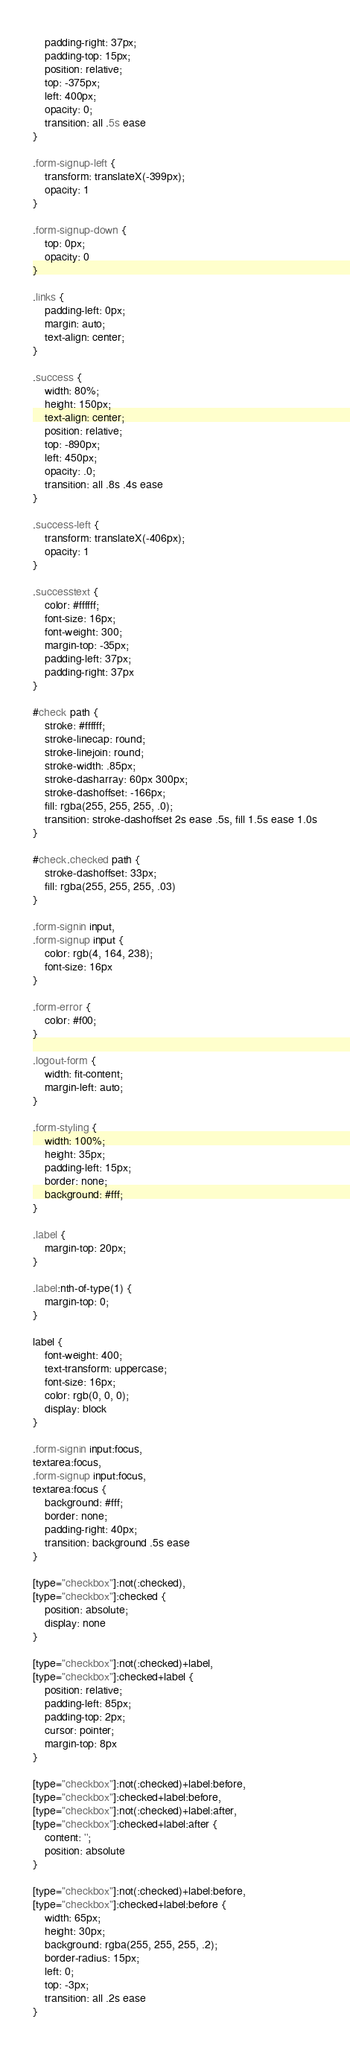<code> <loc_0><loc_0><loc_500><loc_500><_CSS_>    padding-right: 37px;
    padding-top: 15px;
    position: relative;
    top: -375px;
    left: 400px;
    opacity: 0;
    transition: all .5s ease
}

.form-signup-left {
    transform: translateX(-399px);
    opacity: 1
}

.form-signup-down {
    top: 0px;
    opacity: 0
}

.links {
    padding-left: 0px;
    margin: auto;
    text-align: center;
}

.success {
    width: 80%;
    height: 150px;
    text-align: center;
    position: relative;
    top: -890px;
    left: 450px;
    opacity: .0;
    transition: all .8s .4s ease
}

.success-left {
    transform: translateX(-406px);
    opacity: 1
}

.successtext {
    color: #ffffff;
    font-size: 16px;
    font-weight: 300;
    margin-top: -35px;
    padding-left: 37px;
    padding-right: 37px
}

#check path {
    stroke: #ffffff;
    stroke-linecap: round;
    stroke-linejoin: round;
    stroke-width: .85px;
    stroke-dasharray: 60px 300px;
    stroke-dashoffset: -166px;
    fill: rgba(255, 255, 255, .0);
    transition: stroke-dashoffset 2s ease .5s, fill 1.5s ease 1.0s
}

#check.checked path {
    stroke-dashoffset: 33px;
    fill: rgba(255, 255, 255, .03)
}

.form-signin input,
.form-signup input {
    color: rgb(4, 164, 238);
    font-size: 16px
}

.form-error {
    color: #f00;
}

.logout-form {
    width: fit-content;
    margin-left: auto;
}

.form-styling {
    width: 100%;
    height: 35px;
    padding-left: 15px;
    border: none;
    background: #fff;
}

.label {
    margin-top: 20px;
}

.label:nth-of-type(1) {
    margin-top: 0;
}

label {
    font-weight: 400;
    text-transform: uppercase;
    font-size: 16px;
    color: rgb(0, 0, 0);
    display: block
}

.form-signin input:focus,
textarea:focus,
.form-signup input:focus,
textarea:focus {
    background: #fff;
    border: none;
    padding-right: 40px;
    transition: background .5s ease
}

[type="checkbox"]:not(:checked),
[type="checkbox"]:checked {
    position: absolute;
    display: none
}

[type="checkbox"]:not(:checked)+label,
[type="checkbox"]:checked+label {
    position: relative;
    padding-left: 85px;
    padding-top: 2px;
    cursor: pointer;
    margin-top: 8px
}

[type="checkbox"]:not(:checked)+label:before,
[type="checkbox"]:checked+label:before,
[type="checkbox"]:not(:checked)+label:after,
[type="checkbox"]:checked+label:after {
    content: '';
    position: absolute
}

[type="checkbox"]:not(:checked)+label:before,
[type="checkbox"]:checked+label:before {
    width: 65px;
    height: 30px;
    background: rgba(255, 255, 255, .2);
    border-radius: 15px;
    left: 0;
    top: -3px;
    transition: all .2s ease
}
</code> 